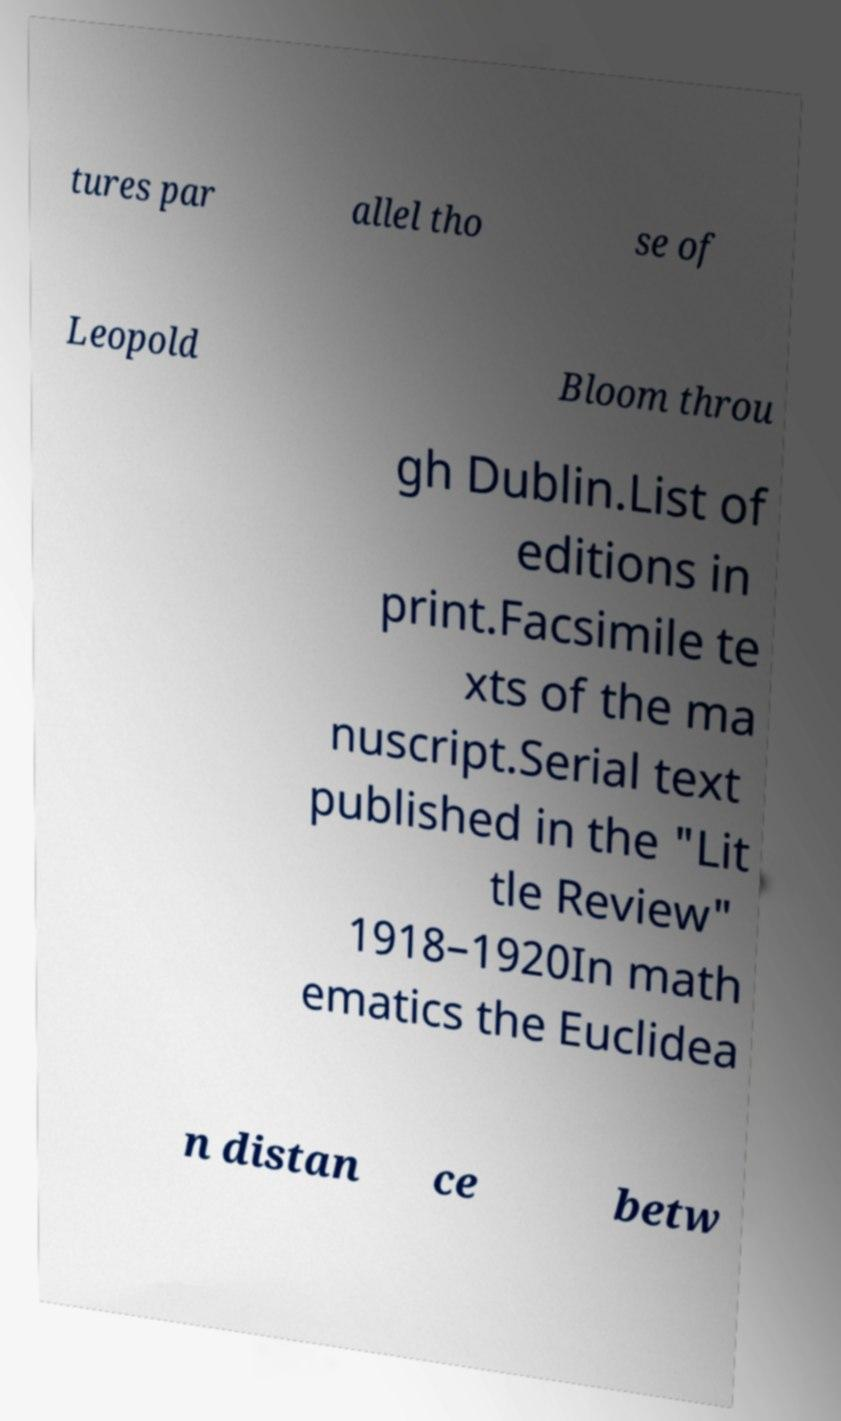Could you extract and type out the text from this image? tures par allel tho se of Leopold Bloom throu gh Dublin.List of editions in print.Facsimile te xts of the ma nuscript.Serial text published in the "Lit tle Review" 1918–1920In math ematics the Euclidea n distan ce betw 